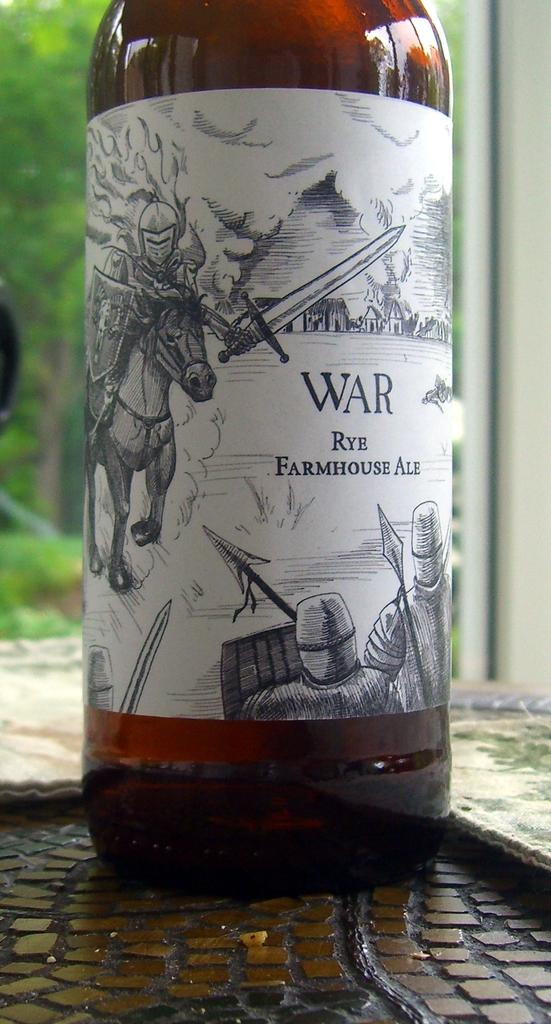<image>
Present a compact description of the photo's key features. A bottle of a farmhouse ale called War sitting on a table. 